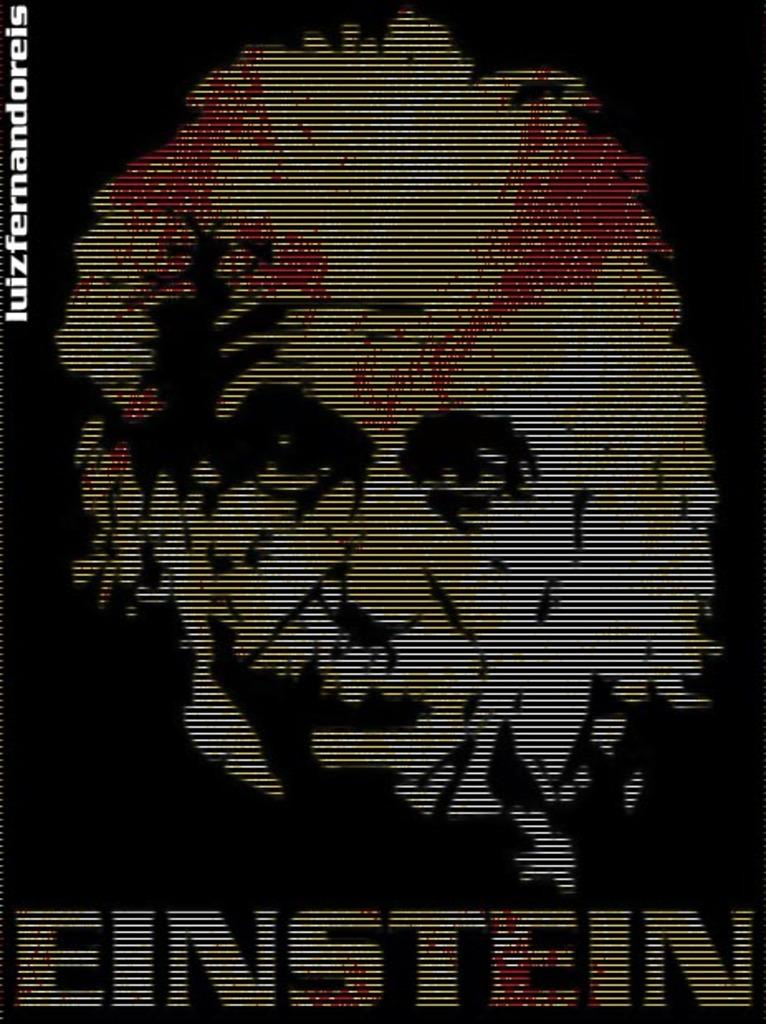<image>
Offer a succinct explanation of the picture presented. A computer screen shows an image in black and white with some red of EINSTEIN. 